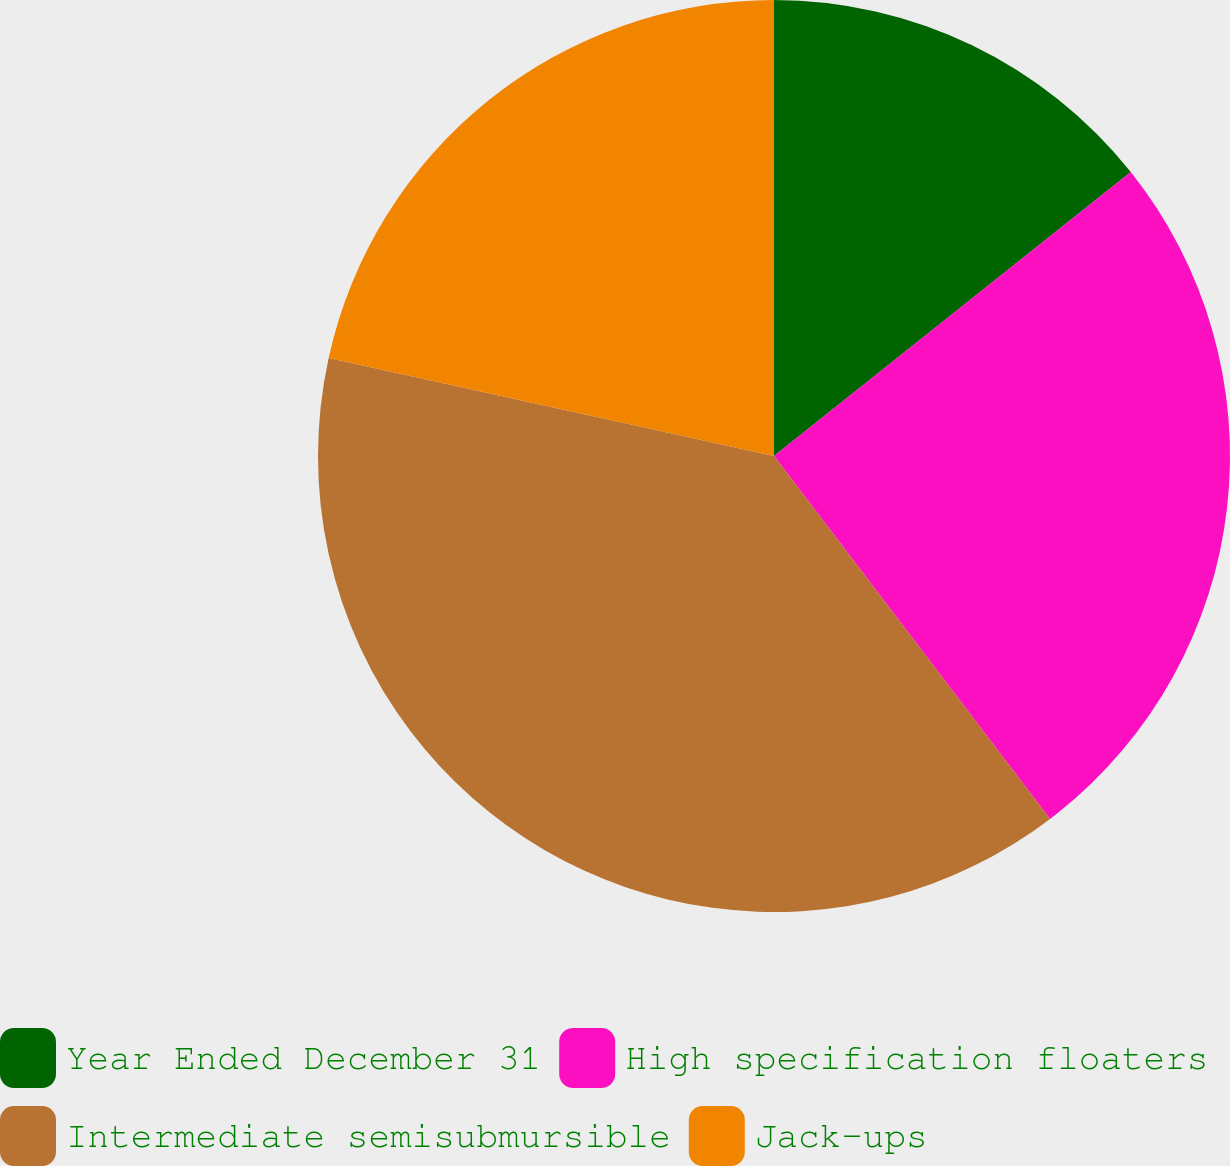Convert chart to OTSL. <chart><loc_0><loc_0><loc_500><loc_500><pie_chart><fcel>Year Ended December 31<fcel>High specification floaters<fcel>Intermediate semisubmursible<fcel>Jack-ups<nl><fcel>14.3%<fcel>25.35%<fcel>38.8%<fcel>21.55%<nl></chart> 